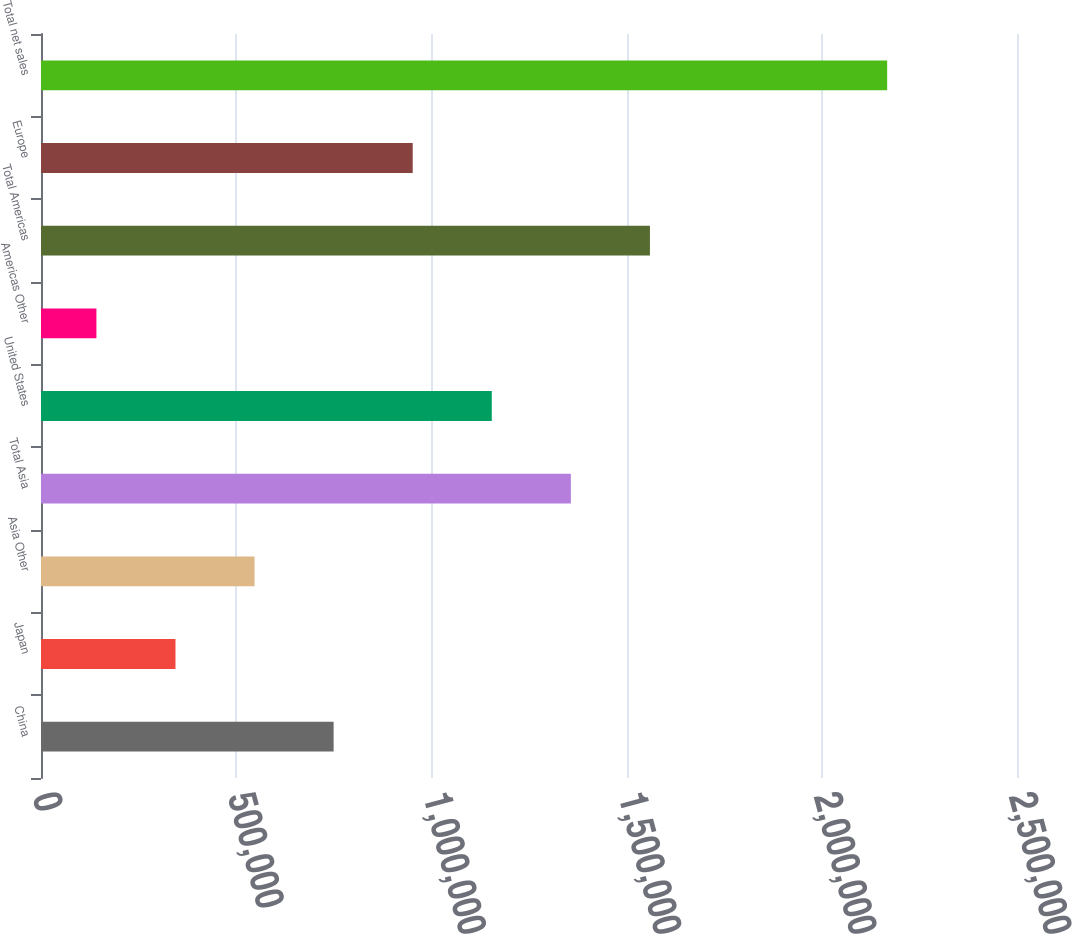Convert chart to OTSL. <chart><loc_0><loc_0><loc_500><loc_500><bar_chart><fcel>China<fcel>Japan<fcel>Asia Other<fcel>Total Asia<fcel>United States<fcel>Americas Other<fcel>Total Americas<fcel>Europe<fcel>Total net sales<nl><fcel>749558<fcel>344454<fcel>547006<fcel>1.35721e+06<fcel>1.15466e+06<fcel>141902<fcel>1.55977e+06<fcel>952110<fcel>2.16742e+06<nl></chart> 